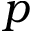<formula> <loc_0><loc_0><loc_500><loc_500>p</formula> 